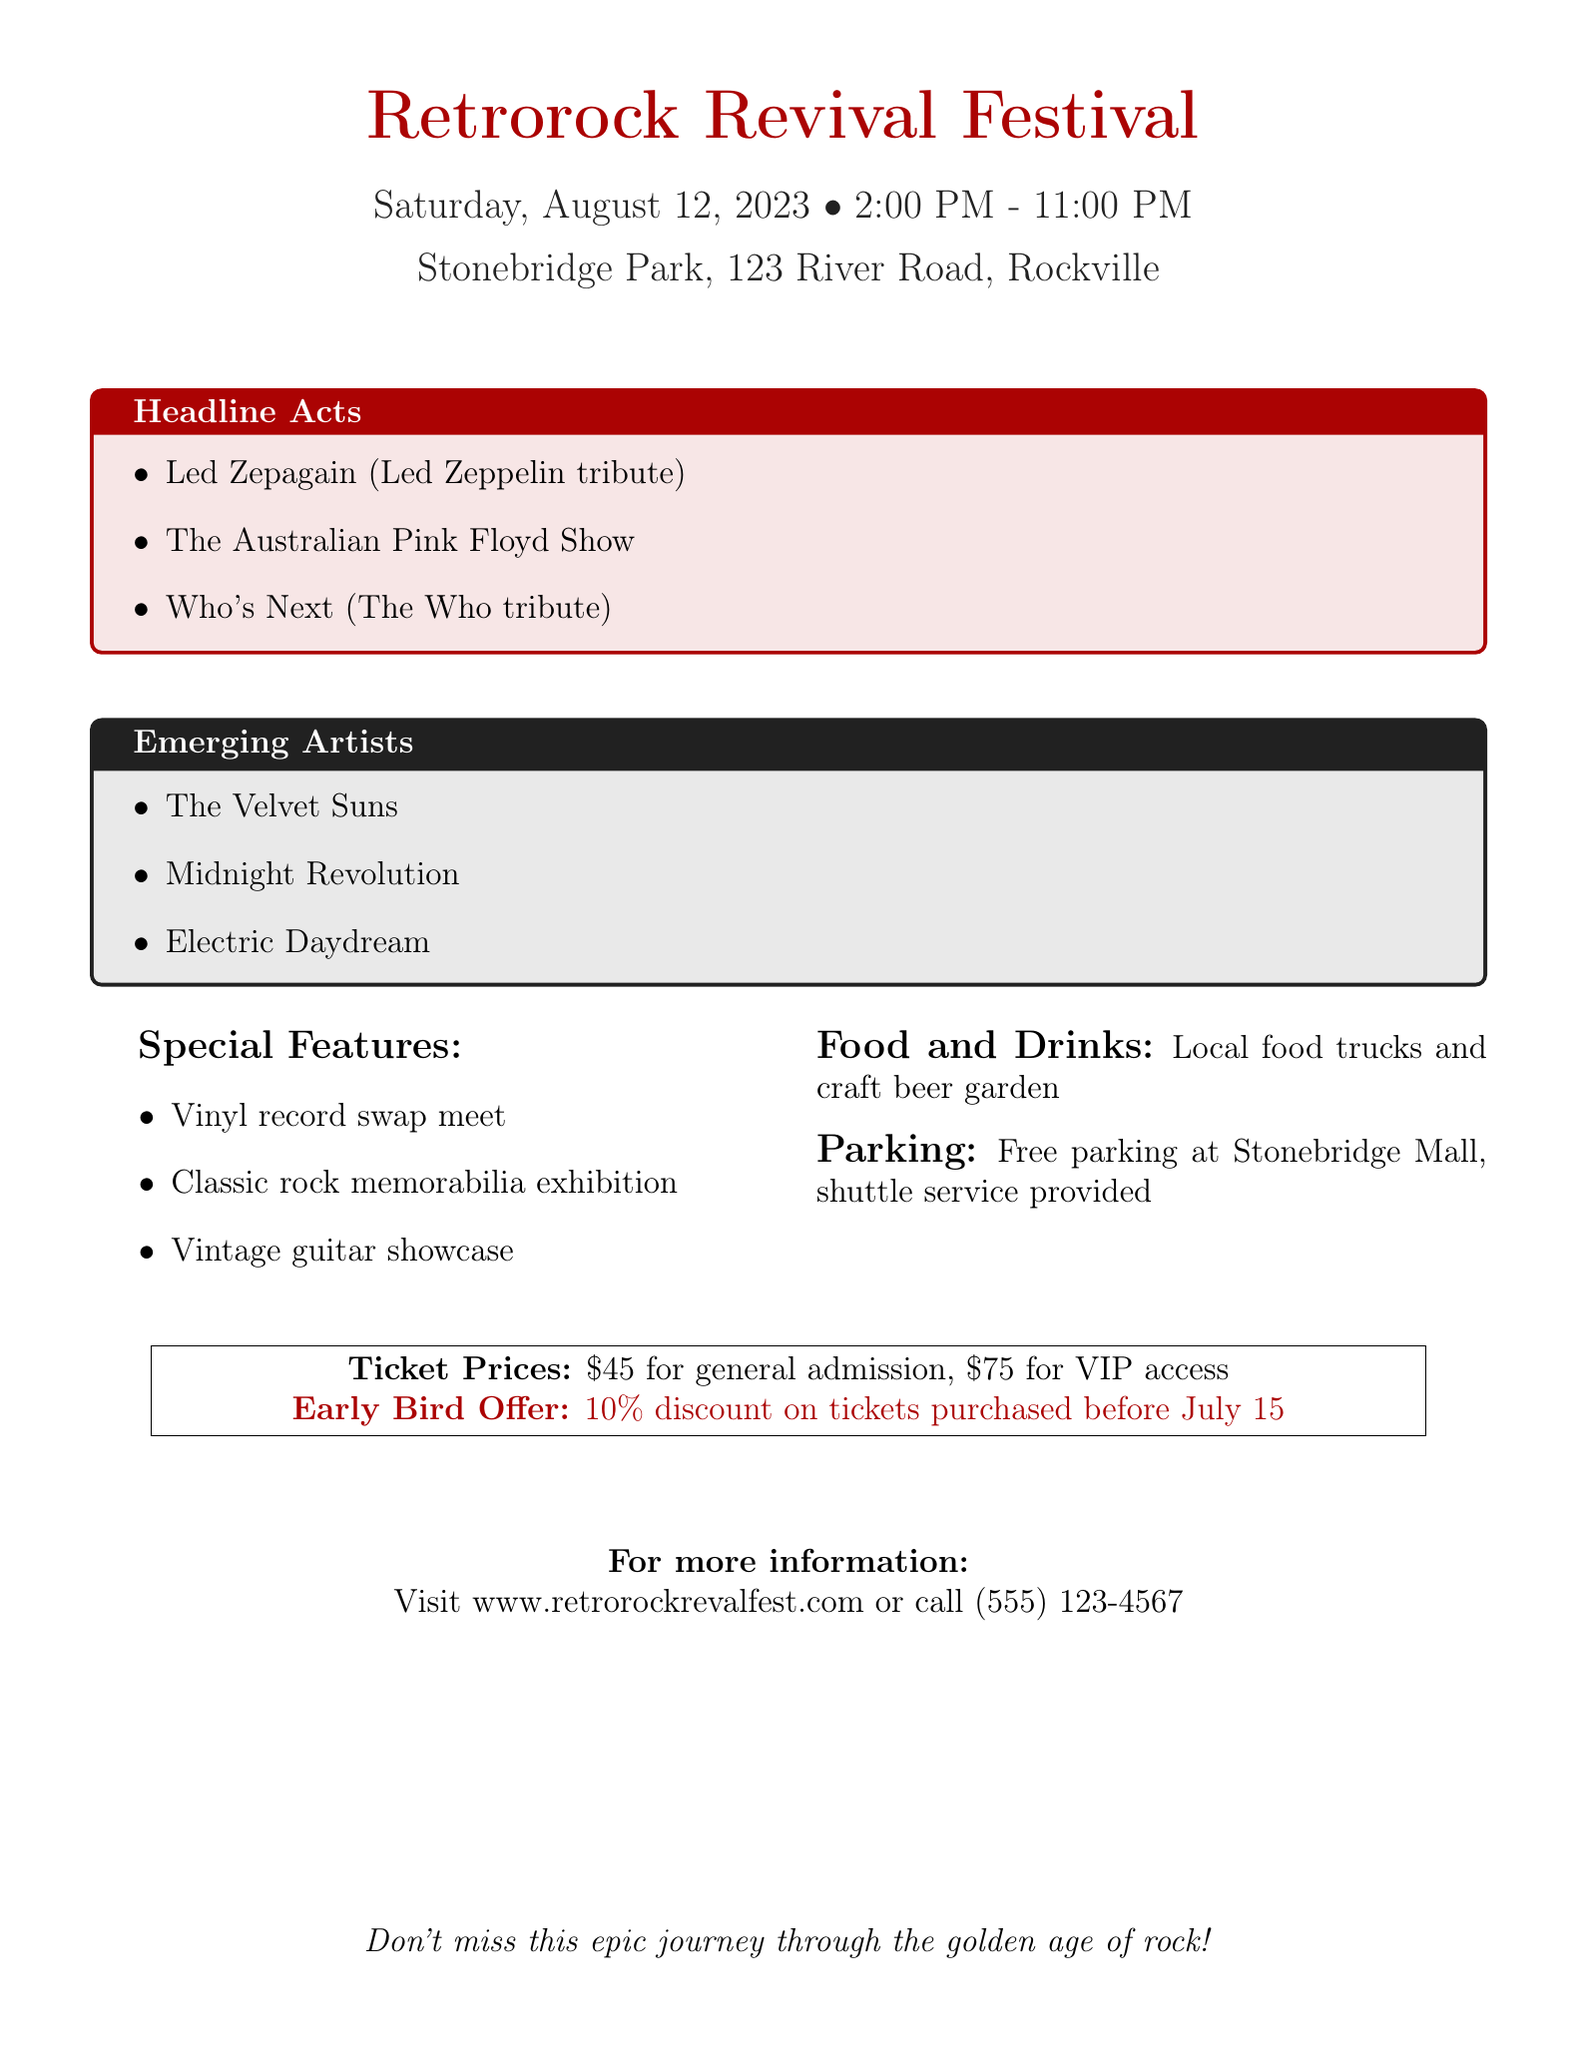What is the name of the festival? The name of the festival is mentioned at the top of the document as "Retrorock Revival Festival."
Answer: Retrorock Revival Festival What is the date of the event? The document specifies the date of the festival as "Saturday, August 12, 2023."
Answer: Saturday, August 12, 2023 What are the ticket prices for general admission? The document lists general admission ticket prices as "$45."
Answer: $45 Who is the tribute act for Led Zeppelin? The document mentions "Led Zepagain" as the tribute act for Led Zeppelin.
Answer: Led Zepagain What special feature involves music collectibles? The document refers to a "Classic rock memorabilia exhibition" as a special feature.
Answer: Classic rock memorabilia exhibition What do VIP tickets cost? The ticket price for VIP access is stated as "$75."
Answer: $75 What type of food options will be available at the festival? The document states that there will be "Local food trucks and craft beer garden" available for food and drinks.
Answer: Local food trucks and craft beer garden Is there an early bird discount? The document mentions an "Early Bird Offer" providing a 10% discount for certain ticket purchases before a specific date.
Answer: Yes Where should attendees go for more information? The document provides the website "www.retrorockrevalfest.com" as a source for more information.
Answer: www.retrorockrevalfest.com 